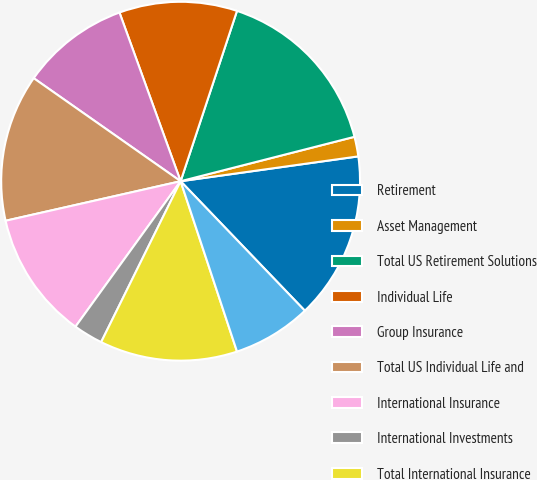Convert chart. <chart><loc_0><loc_0><loc_500><loc_500><pie_chart><fcel>Retirement<fcel>Asset Management<fcel>Total US Retirement Solutions<fcel>Individual Life<fcel>Group Insurance<fcel>Total US Individual Life and<fcel>International Insurance<fcel>International Investments<fcel>Total International Insurance<fcel>Corporate Operations<nl><fcel>15.04%<fcel>1.77%<fcel>15.93%<fcel>10.62%<fcel>9.73%<fcel>13.27%<fcel>11.5%<fcel>2.66%<fcel>12.39%<fcel>7.08%<nl></chart> 